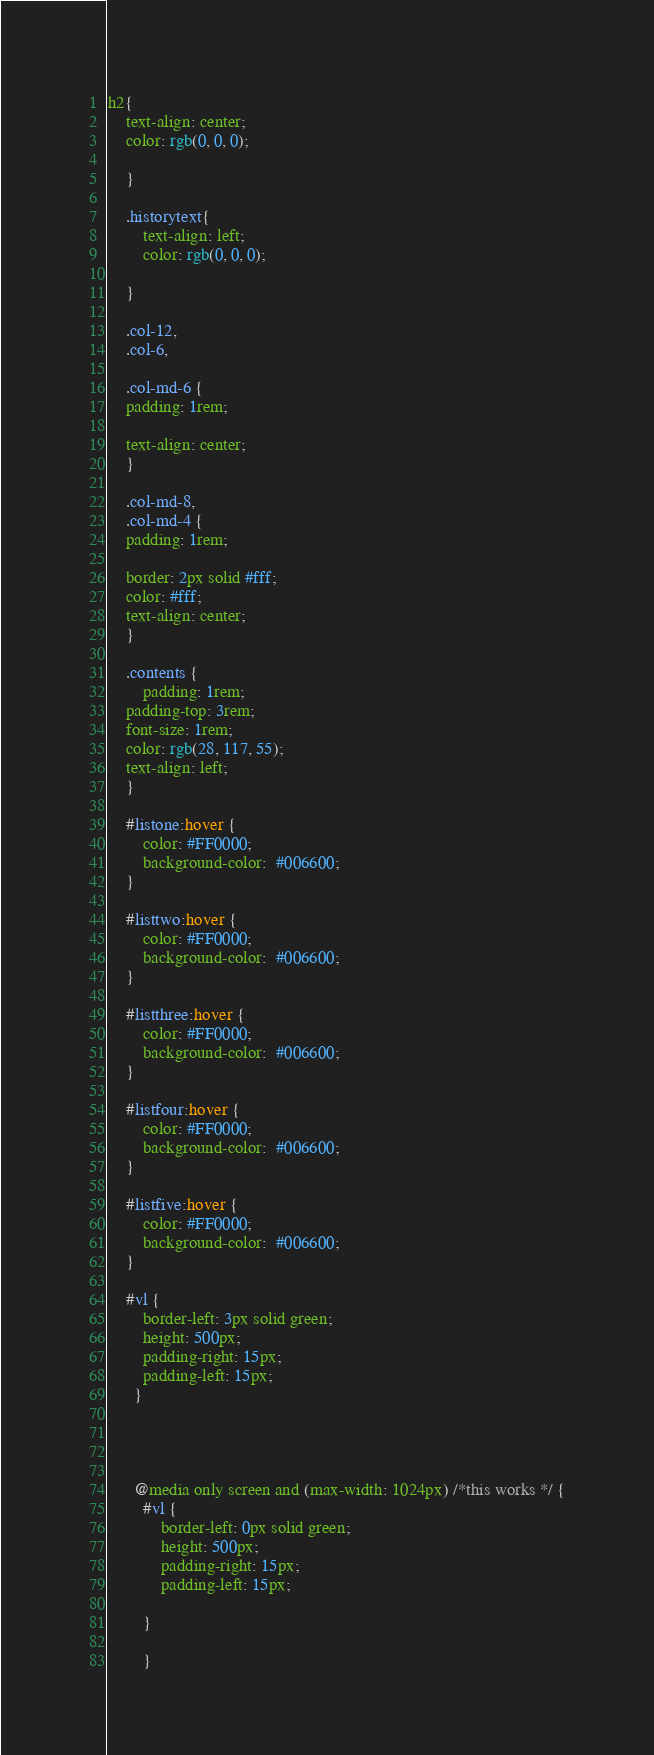<code> <loc_0><loc_0><loc_500><loc_500><_CSS_>h2{
    text-align: center;
    color: rgb(0, 0, 0);
    
    }
    
    .historytext{
        text-align: left;
        color: rgb(0, 0, 0);
        
    }
    
    .col-12,
    .col-6,
    
    .col-md-6 {
    padding: 1rem;
    
    text-align: center;
    }
    
    .col-md-8,
    .col-md-4 {
    padding: 1rem;
    
    border: 2px solid #fff;
    color: #fff;
    text-align: center;
    }
     
    .contents {
        padding: 1rem;
    padding-top: 3rem;
    font-size: 1rem;
    color: rgb(28, 117, 55);
    text-align: left;
    }
    
    #listone:hover {
        color: #FF0000;
        background-color:  #006600;
    }
    
    #listtwo:hover {
        color: #FF0000;
        background-color:  #006600;
    }
    
    #listthree:hover {
        color: #FF0000;
        background-color:  #006600;
    }
    
    #listfour:hover {
        color: #FF0000;
        background-color:  #006600;
    }
    
    #listfive:hover {
        color: #FF0000;
        background-color:  #006600;
    }
    
    #vl {
        border-left: 3px solid green;
        height: 500px;
        padding-right: 15px;
        padding-left: 15px;
      }
    
     
    
    
      @media only screen and (max-width: 1024px) /*this works */ {
        #vl {
            border-left: 0px solid green;
            height: 500px;
            padding-right: 15px;
            padding-left: 15px;
         
        }
        
        }</code> 